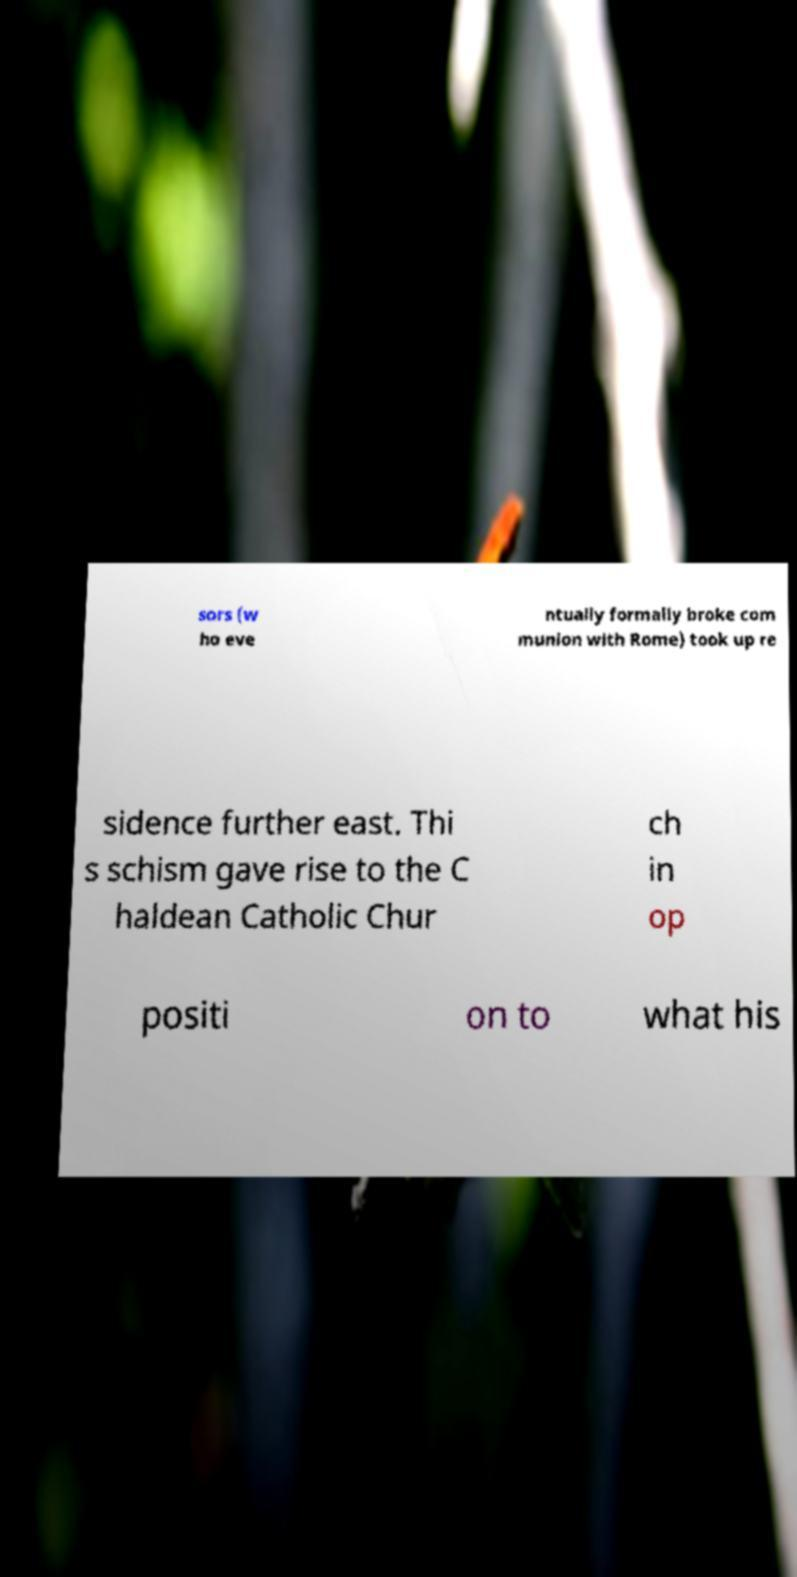There's text embedded in this image that I need extracted. Can you transcribe it verbatim? sors (w ho eve ntually formally broke com munion with Rome) took up re sidence further east. Thi s schism gave rise to the C haldean Catholic Chur ch in op positi on to what his 